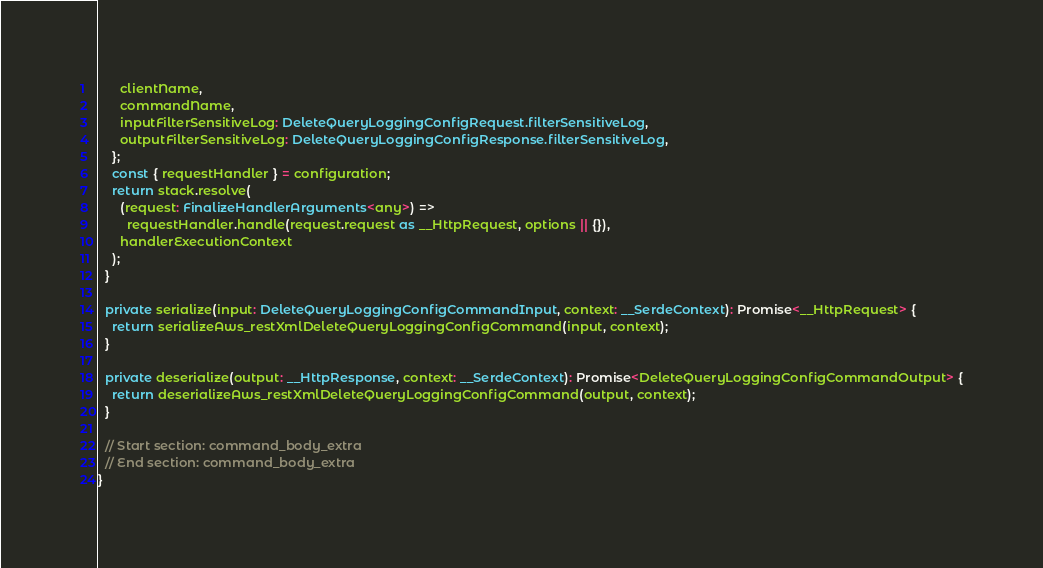Convert code to text. <code><loc_0><loc_0><loc_500><loc_500><_TypeScript_>      clientName,
      commandName,
      inputFilterSensitiveLog: DeleteQueryLoggingConfigRequest.filterSensitiveLog,
      outputFilterSensitiveLog: DeleteQueryLoggingConfigResponse.filterSensitiveLog,
    };
    const { requestHandler } = configuration;
    return stack.resolve(
      (request: FinalizeHandlerArguments<any>) =>
        requestHandler.handle(request.request as __HttpRequest, options || {}),
      handlerExecutionContext
    );
  }

  private serialize(input: DeleteQueryLoggingConfigCommandInput, context: __SerdeContext): Promise<__HttpRequest> {
    return serializeAws_restXmlDeleteQueryLoggingConfigCommand(input, context);
  }

  private deserialize(output: __HttpResponse, context: __SerdeContext): Promise<DeleteQueryLoggingConfigCommandOutput> {
    return deserializeAws_restXmlDeleteQueryLoggingConfigCommand(output, context);
  }

  // Start section: command_body_extra
  // End section: command_body_extra
}
</code> 